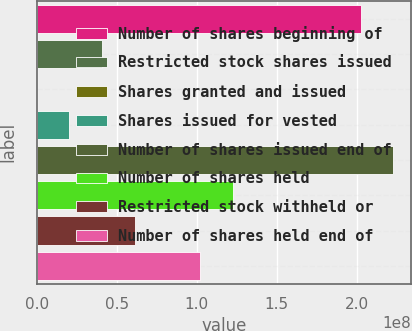Convert chart to OTSL. <chart><loc_0><loc_0><loc_500><loc_500><bar_chart><fcel>Number of shares beginning of<fcel>Restricted stock shares issued<fcel>Shares granted and issued<fcel>Shares issued for vested<fcel>Number of shares issued end of<fcel>Number of shares held<fcel>Restricted stock withheld or<fcel>Number of shares held end of<nl><fcel>2.02529e+08<fcel>4.09624e+07<fcel>37824<fcel>2.05001e+07<fcel>2.22991e+08<fcel>1.22812e+08<fcel>6.14247e+07<fcel>1.02349e+08<nl></chart> 